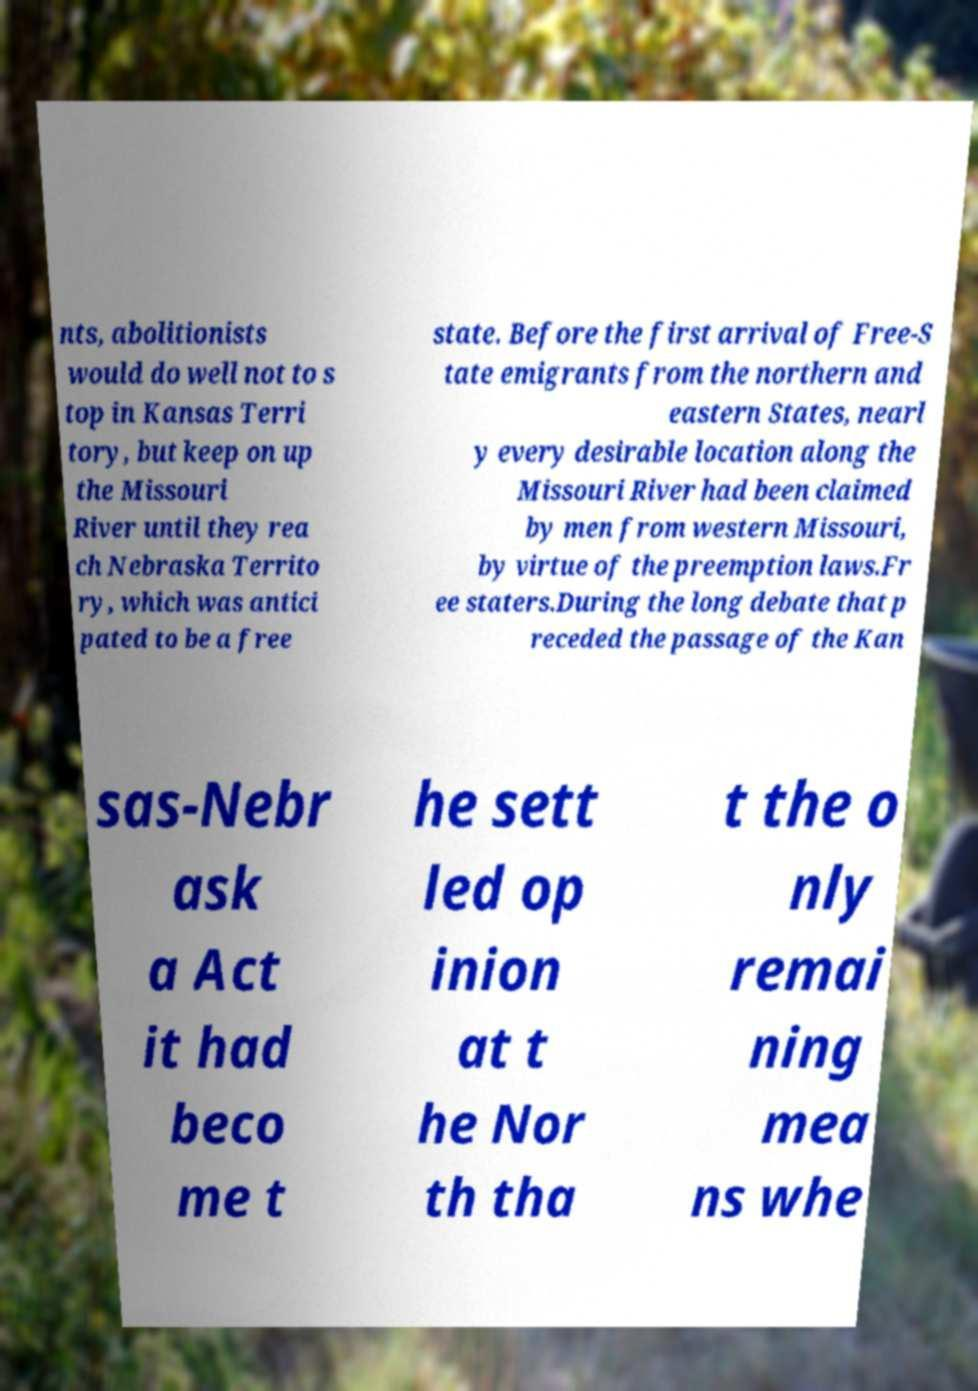For documentation purposes, I need the text within this image transcribed. Could you provide that? nts, abolitionists would do well not to s top in Kansas Terri tory, but keep on up the Missouri River until they rea ch Nebraska Territo ry, which was antici pated to be a free state. Before the first arrival of Free-S tate emigrants from the northern and eastern States, nearl y every desirable location along the Missouri River had been claimed by men from western Missouri, by virtue of the preemption laws.Fr ee staters.During the long debate that p receded the passage of the Kan sas-Nebr ask a Act it had beco me t he sett led op inion at t he Nor th tha t the o nly remai ning mea ns whe 